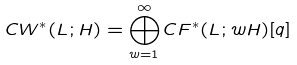<formula> <loc_0><loc_0><loc_500><loc_500>C W ^ { * } ( L ; H ) = \bigoplus _ { w = 1 } ^ { \infty } C F ^ { * } ( L ; w H ) [ q ]</formula> 